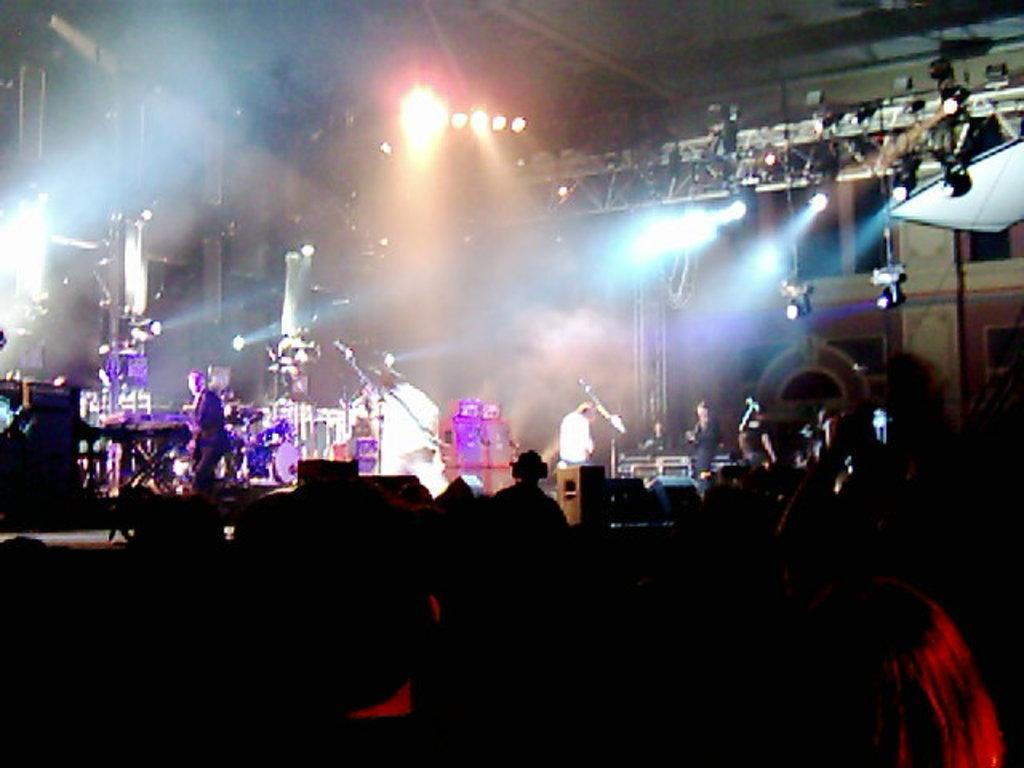How many people are in the image? There are people in the image, but the exact number is not specified. What are the people doing in the image? The people are likely playing musical instruments, as they are mentioned as being present in the image. What can be seen in the image besides the people and musical instruments? There are lights, poles, and other objects in the image. What is the overall lighting condition in the image? The image is described as being dark. What type of food can be seen in the lunchroom in the image? There is no mention of a lunchroom in the image, so it cannot be determined if any food is present. What sound can be heard coming from the moon in the image? There is no mention of the moon or any sounds in the image, so it cannot be determined what sound might be heard. 